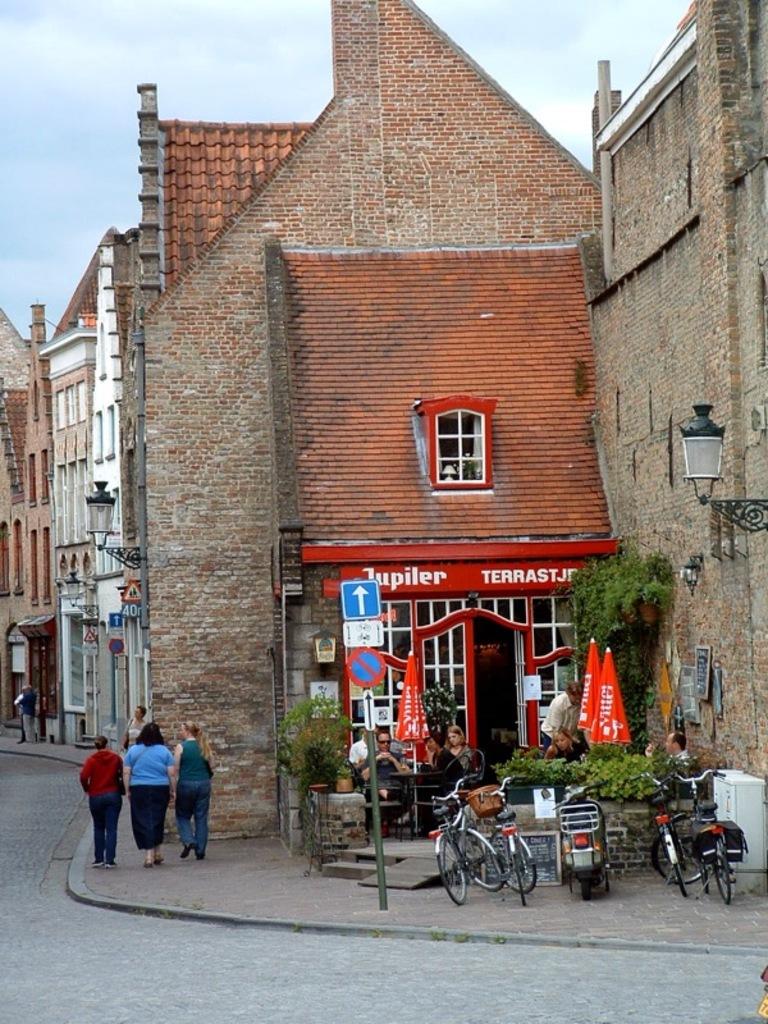What's the name of the restaurant with the red paint?
Your answer should be compact. Jupiter. 